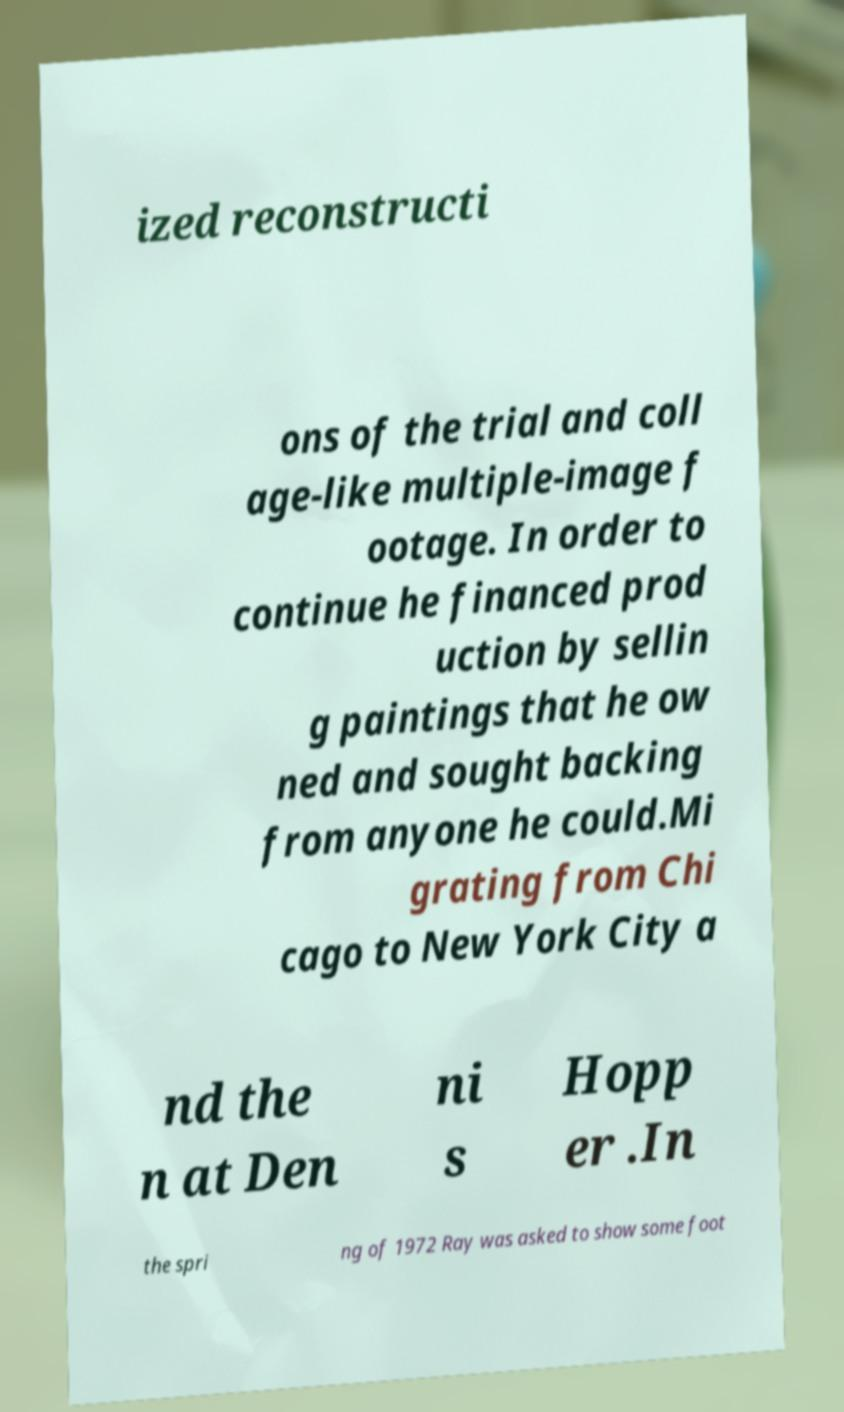What messages or text are displayed in this image? I need them in a readable, typed format. ized reconstructi ons of the trial and coll age-like multiple-image f ootage. In order to continue he financed prod uction by sellin g paintings that he ow ned and sought backing from anyone he could.Mi grating from Chi cago to New York City a nd the n at Den ni s Hopp er .In the spri ng of 1972 Ray was asked to show some foot 